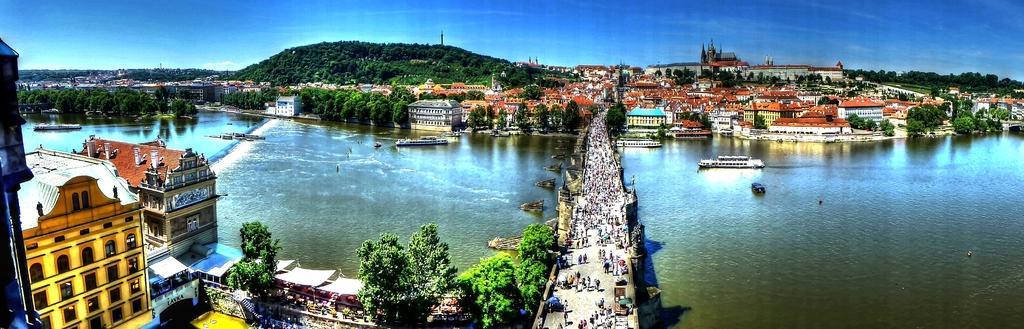Could you give a brief overview of what you see in this image? In this image I can see water and on it I can see few boats. On the both sides of the water I can see number of trees and number of buildings. I can also see a road over the water and on the road I can see number of people are standing. On the top side of this image I can see the sky. 